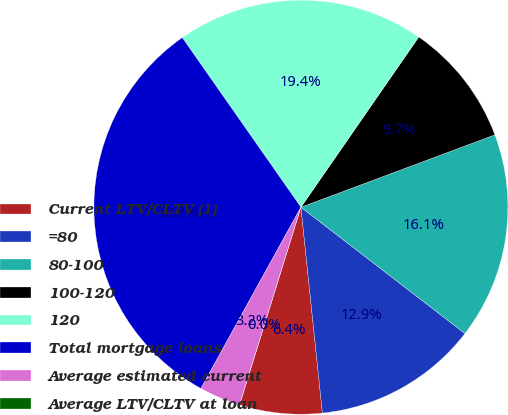Convert chart. <chart><loc_0><loc_0><loc_500><loc_500><pie_chart><fcel>Current LTV/CLTV (1)<fcel>=80<fcel>80-100<fcel>100-120<fcel>120<fcel>Total mortgage loans<fcel>Average estimated current<fcel>Average LTV/CLTV at loan<nl><fcel>6.45%<fcel>12.9%<fcel>16.13%<fcel>9.68%<fcel>19.35%<fcel>32.26%<fcel>3.23%<fcel>0.0%<nl></chart> 